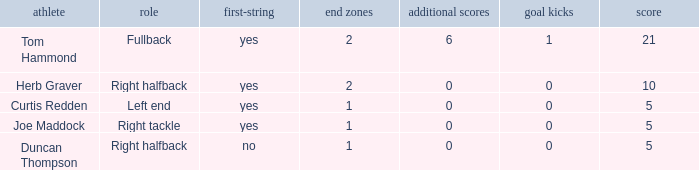What is the total points awarded for a field goal being worth 1 point? 1.0. 